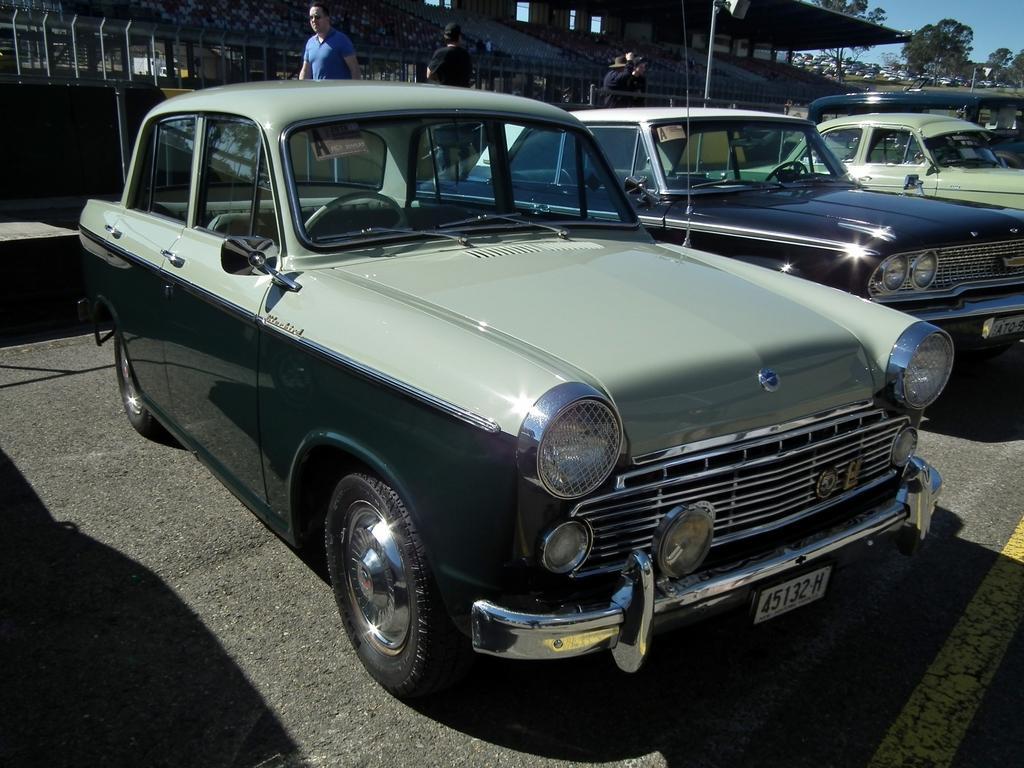Can you describe this image briefly? In this image we can see these cars are parked on the road. In the background, we can see these people are walking on the sidewalk, we can see fence, buildings, trees and the sky. 